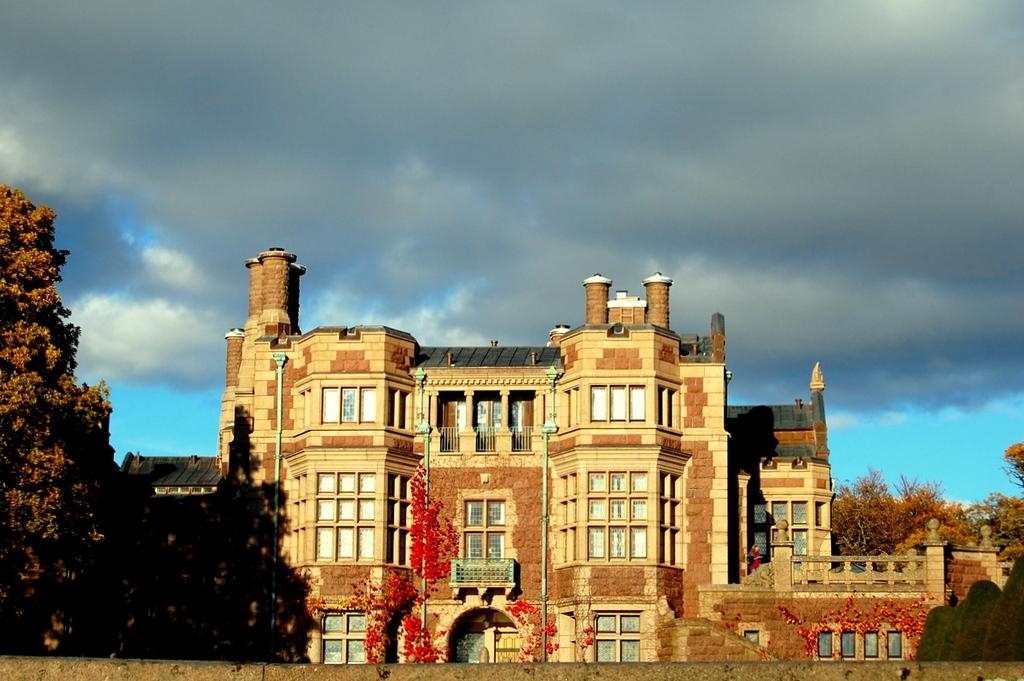What type of structure is present in the image? There is a building in the image. What other natural elements can be seen in the image? There are trees and flowers in the image. What is visible in the background of the image? The sky is visible in the background of the image. What can be observed in the sky? There are clouds in the sky. What brand of toothpaste is advertised on the canvas in the image? There is no canvas or toothpaste present in the image. How many cats can be seen playing with the flowers in the image? There are no cats present in the image; it features a building, trees, flowers, and clouds. 